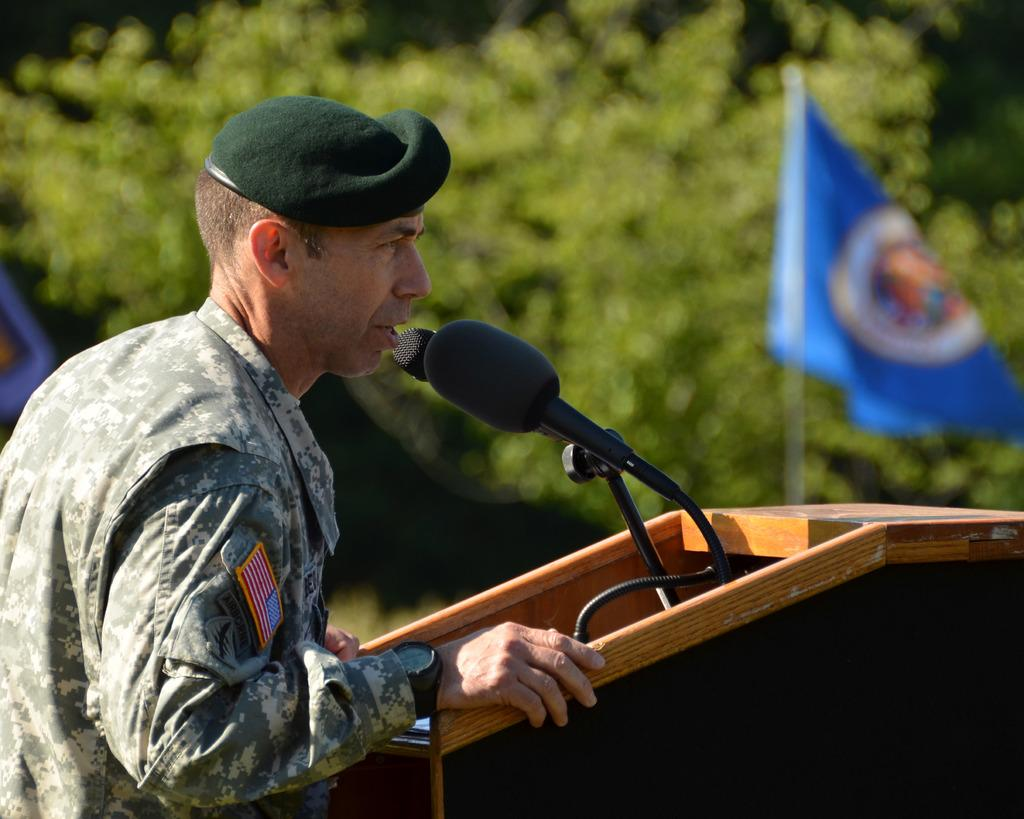What is the man in the image wearing? The man is wearing an army uniform. What is in front of the man? There is a podium and a microphone in front of the man. What can be seen in the background of the image? There is a tree and a flag in the background of the image. What time of day is it in the image, and how does the cow contribute to the scene? There is no cow present in the image, and the time of day cannot be determined from the image alone. 